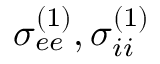<formula> <loc_0><loc_0><loc_500><loc_500>\sigma _ { e e } ^ { ( 1 ) } , \sigma _ { i i } ^ { ( 1 ) }</formula> 